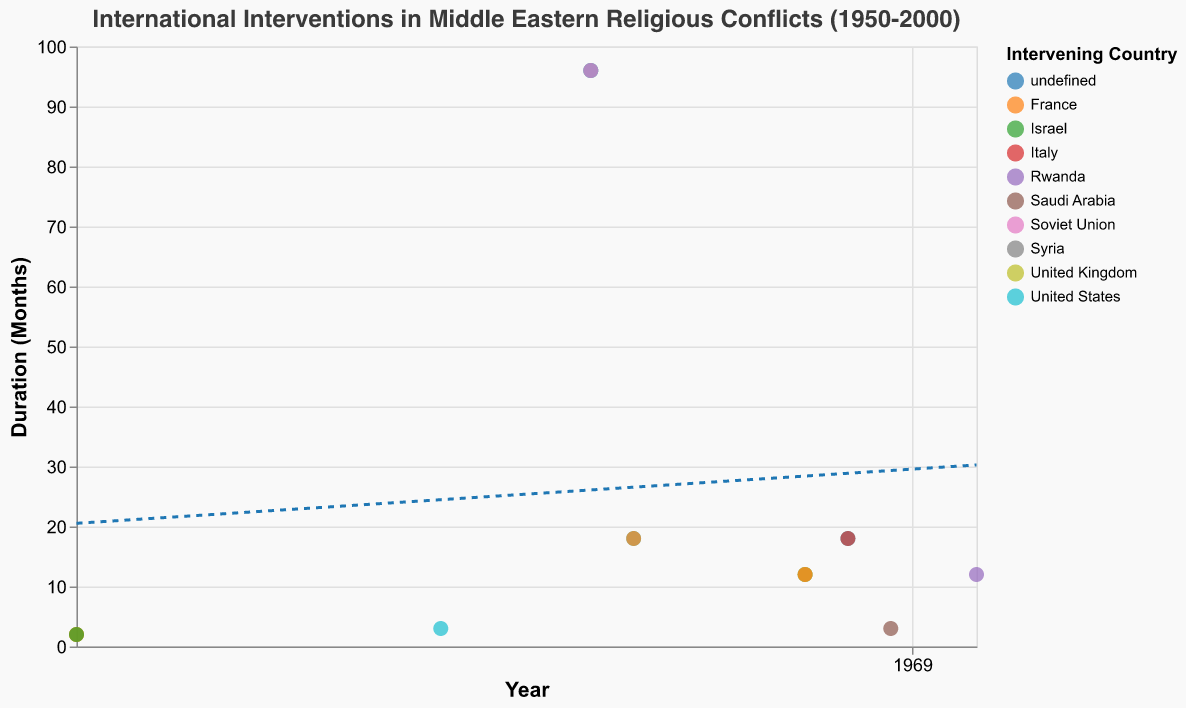What is the title of the figure? The title is usually positioned at the top of the figure and is in plain text. In this figure, it reads "International Interventions in Middle Eastern Religious Conflicts (1950-2000)."
Answer: International Interventions in Middle Eastern Religious Conflicts (1950-2000) What is the range of years represented on the x-axis? The x-axis, which is temporal, has tick marks and labels showing the range of years from the earliest to the latest. The earliest year is 1956 and the latest is 1998.
Answer: 1956-1998 How many data points are there for the United States' interventions, and what are their durations? To answer, count the number of points with the color corresponding to United States interventions and note their y-axis values. There are five points, with durations of 3, 96, 18, 12, and 18 months, respectively.
Answer: 5 data points (3, 96, 18, 12, 18) Which conflict had the longest duration of intervention and by which countries? Look for the highest point on the y-axis to identify the longest duration and then check the tooltip or color code for the corresponding countries. The Iran-Iraq War had the longest interventions (96 months) by Syria, United States, and the Soviet Union.
Answer: Iran-Iraq War by Syria, United States, and the Soviet Union What does the trend line indicate about the duration of interventions over time? Evaluate the direction and slope of the trend line. The trend line is a regression line indicating the overall pattern. If it slopes upwards, it suggests that the duration of interventions has generally increased over time, and vice versa.
Answer: Increasing duration over time Between which years did the United States intervene the most based on the number of interventions shown? Count the number of data points labeled for the United States across the years and identify where the count is highest. The year with the highest count (3) is 1980 (Iran-Iraq War).
Answer: 1980 Compare the duration of interventions in the Suez Crisis versus the Gulf War. Which had a longer duration, and by how many months? Check the durations for both conflicts. The Suez Crisis interventions were all 2 months each, and the Gulf War interventions were all 12 months each. The Gulf War had a longer duration by 10 months (12 - 2).
Answer: Gulf War by 10 months How many different countries are represented in the interventions, and list them? Identify all unique countries based on the color categorization or tooltip information. The different countries are United Kingdom, France, Israel, United States, Syria, Soviet Union, Italy, Saudi Arabia, Rwanda.
Answer: 9 countries (United Kingdom, France, Israel, United States, Syria, Soviet Union, Italy, Saudi Arabia, Rwanda) What is the average duration of interventions during the 1980s? Calculate the average for the data points within the 1980s (1980-1989). Durations within this range are 96, 96, 96, 18, and 18 months. The average is (96+96+96+18+18)/5 = 64.8 months.
Answer: 64.8 months 